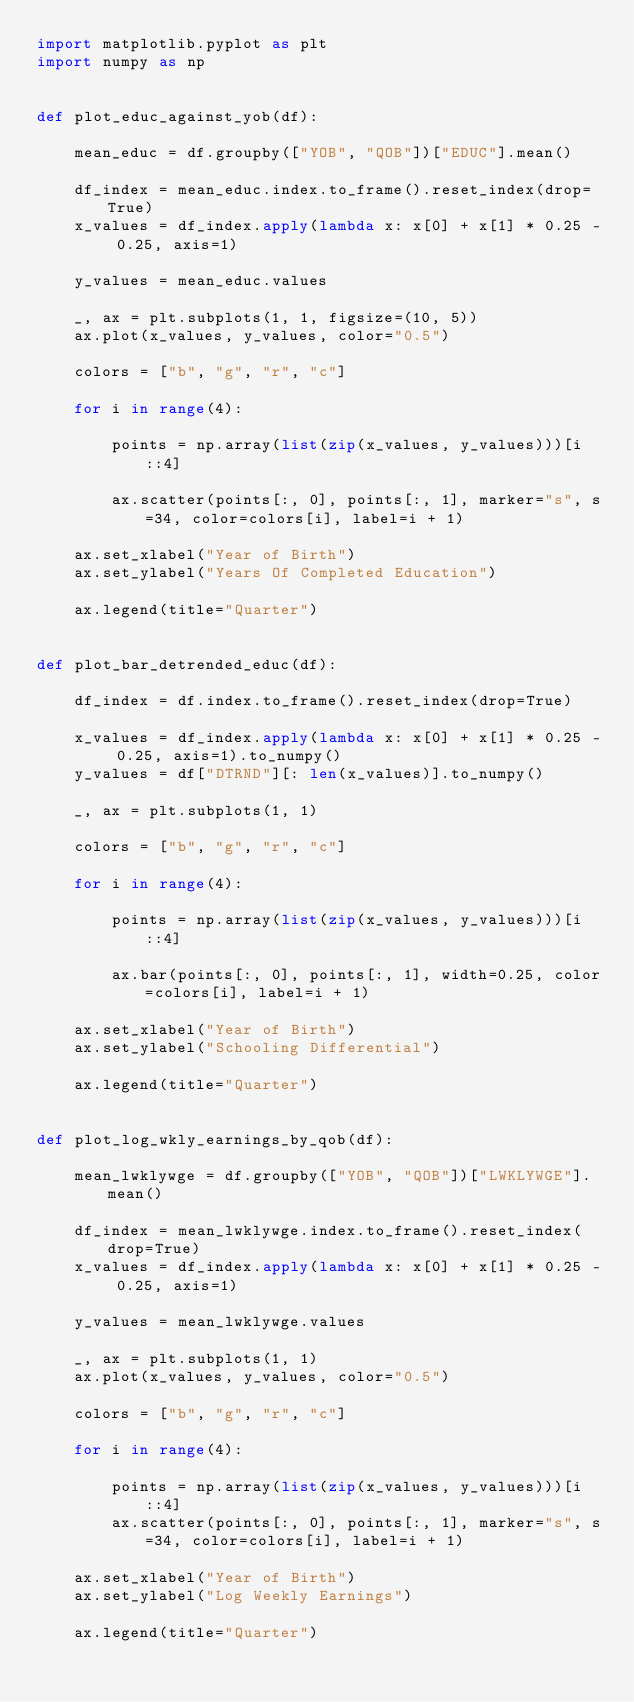Convert code to text. <code><loc_0><loc_0><loc_500><loc_500><_Python_>import matplotlib.pyplot as plt
import numpy as np


def plot_educ_against_yob(df):

    mean_educ = df.groupby(["YOB", "QOB"])["EDUC"].mean()

    df_index = mean_educ.index.to_frame().reset_index(drop=True)
    x_values = df_index.apply(lambda x: x[0] + x[1] * 0.25 - 0.25, axis=1)

    y_values = mean_educ.values

    _, ax = plt.subplots(1, 1, figsize=(10, 5))
    ax.plot(x_values, y_values, color="0.5")

    colors = ["b", "g", "r", "c"]

    for i in range(4):

        points = np.array(list(zip(x_values, y_values)))[i::4]

        ax.scatter(points[:, 0], points[:, 1], marker="s", s=34, color=colors[i], label=i + 1)

    ax.set_xlabel("Year of Birth")
    ax.set_ylabel("Years Of Completed Education")

    ax.legend(title="Quarter")


def plot_bar_detrended_educ(df):

    df_index = df.index.to_frame().reset_index(drop=True)

    x_values = df_index.apply(lambda x: x[0] + x[1] * 0.25 - 0.25, axis=1).to_numpy()
    y_values = df["DTRND"][: len(x_values)].to_numpy()

    _, ax = plt.subplots(1, 1)

    colors = ["b", "g", "r", "c"]

    for i in range(4):

        points = np.array(list(zip(x_values, y_values)))[i::4]

        ax.bar(points[:, 0], points[:, 1], width=0.25, color=colors[i], label=i + 1)

    ax.set_xlabel("Year of Birth")
    ax.set_ylabel("Schooling Differential")

    ax.legend(title="Quarter")


def plot_log_wkly_earnings_by_qob(df):

    mean_lwklywge = df.groupby(["YOB", "QOB"])["LWKLYWGE"].mean()

    df_index = mean_lwklywge.index.to_frame().reset_index(drop=True)
    x_values = df_index.apply(lambda x: x[0] + x[1] * 0.25 - 0.25, axis=1)

    y_values = mean_lwklywge.values

    _, ax = plt.subplots(1, 1)
    ax.plot(x_values, y_values, color="0.5")

    colors = ["b", "g", "r", "c"]

    for i in range(4):

        points = np.array(list(zip(x_values, y_values)))[i::4]
        ax.scatter(points[:, 0], points[:, 1], marker="s", s=34, color=colors[i], label=i + 1)

    ax.set_xlabel("Year of Birth")
    ax.set_ylabel("Log Weekly Earnings")

    ax.legend(title="Quarter")
</code> 